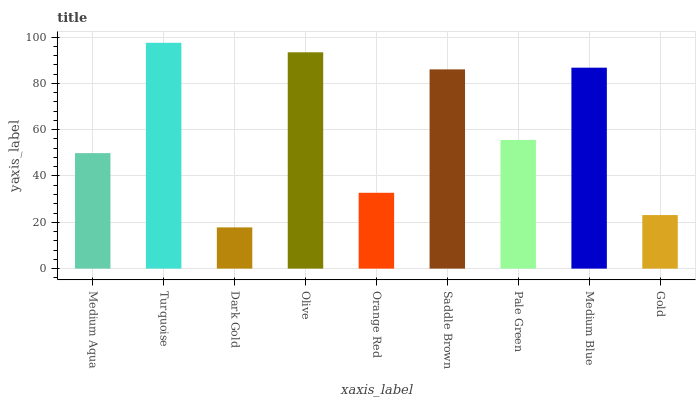Is Dark Gold the minimum?
Answer yes or no. Yes. Is Turquoise the maximum?
Answer yes or no. Yes. Is Turquoise the minimum?
Answer yes or no. No. Is Dark Gold the maximum?
Answer yes or no. No. Is Turquoise greater than Dark Gold?
Answer yes or no. Yes. Is Dark Gold less than Turquoise?
Answer yes or no. Yes. Is Dark Gold greater than Turquoise?
Answer yes or no. No. Is Turquoise less than Dark Gold?
Answer yes or no. No. Is Pale Green the high median?
Answer yes or no. Yes. Is Pale Green the low median?
Answer yes or no. Yes. Is Medium Aqua the high median?
Answer yes or no. No. Is Medium Blue the low median?
Answer yes or no. No. 